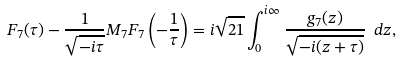<formula> <loc_0><loc_0><loc_500><loc_500>F _ { 7 } ( \tau ) - \frac { 1 } { \sqrt { - i \tau } } M _ { 7 } F _ { 7 } \left ( - \frac { 1 } { \tau } \right ) = i \sqrt { 2 1 } \int _ { 0 } ^ { i \infty } \frac { g _ { 7 } ( z ) } { \sqrt { - i ( z + \tau ) } } \ d z ,</formula> 